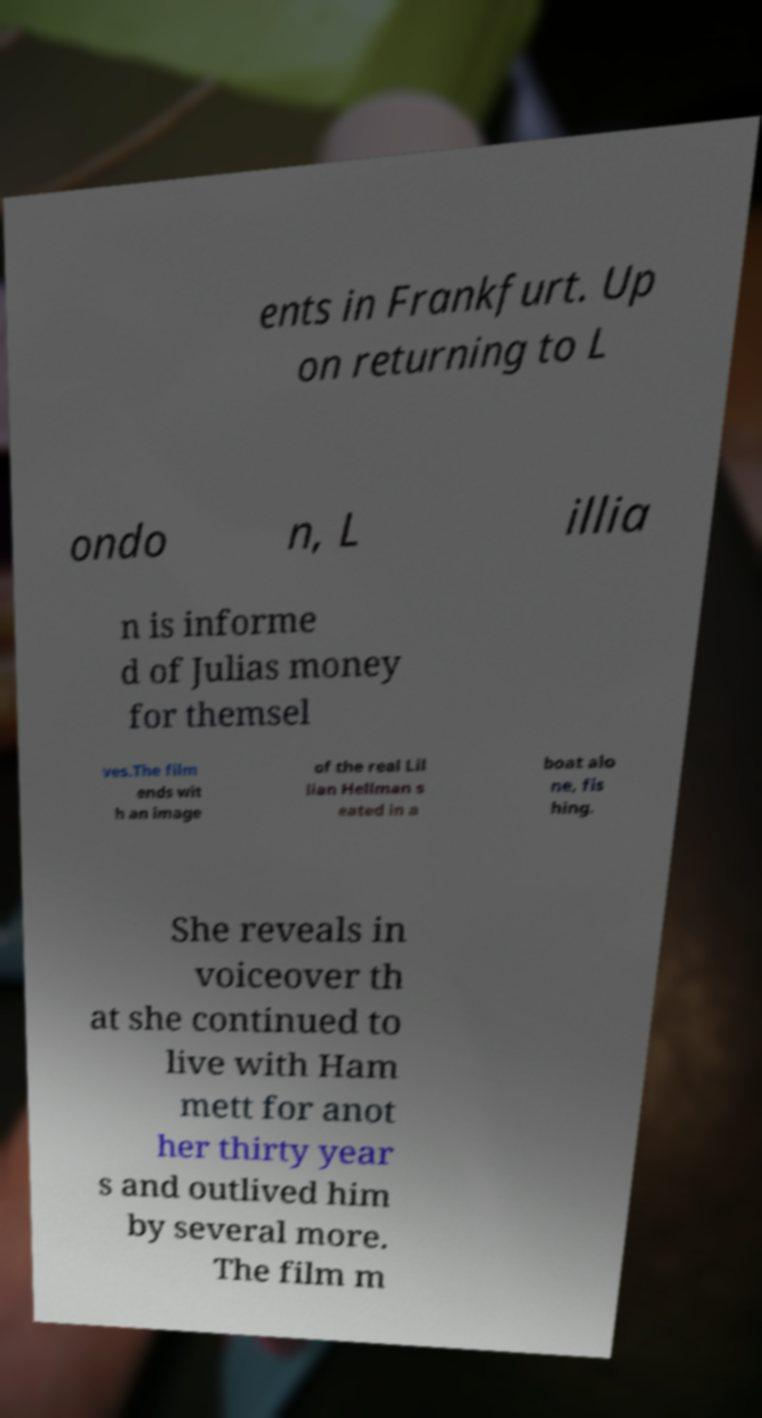What messages or text are displayed in this image? I need them in a readable, typed format. ents in Frankfurt. Up on returning to L ondo n, L illia n is informe d of Julias money for themsel ves.The film ends wit h an image of the real Lil lian Hellman s eated in a boat alo ne, fis hing. She reveals in voiceover th at she continued to live with Ham mett for anot her thirty year s and outlived him by several more. The film m 